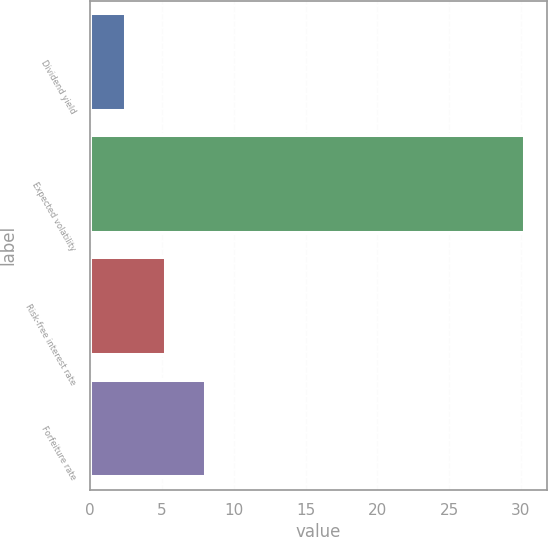Convert chart. <chart><loc_0><loc_0><loc_500><loc_500><bar_chart><fcel>Dividend yield<fcel>Expected volatility<fcel>Risk-free interest rate<fcel>Forfeiture rate<nl><fcel>2.5<fcel>30.3<fcel>5.28<fcel>8.06<nl></chart> 